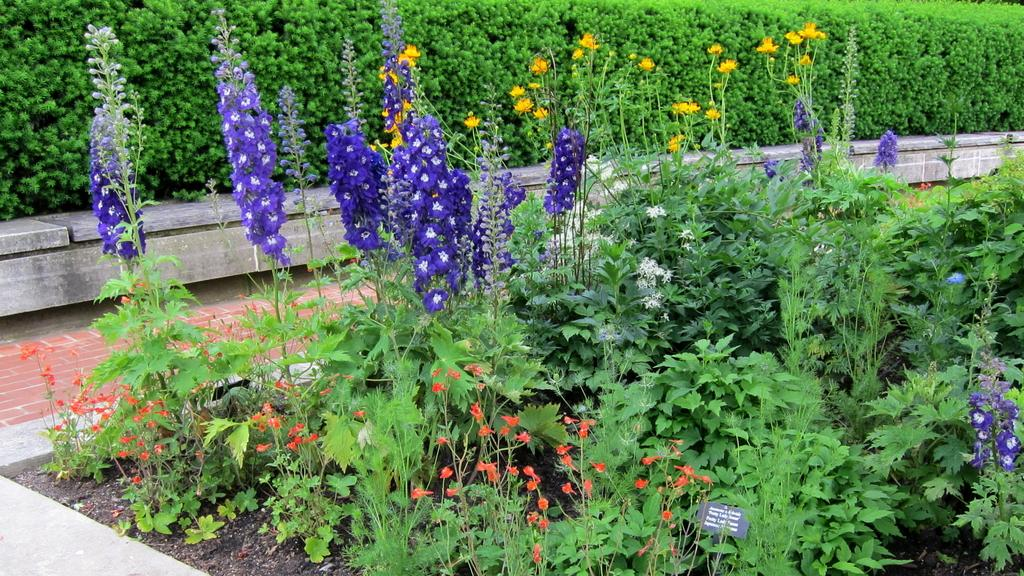What type of vegetation can be seen in the image? There are bushes and plants with flowers in the image. What can be seen beneath the vegetation in the image? The ground is visible in the image. Is there any informational signage in the image? Yes, there is an information board in the image. What type of bells can be heard ringing in the image? There are no bells present in the image, and therefore no sounds can be heard. What is the height of the pail in the image? There is no pail present in the image. 